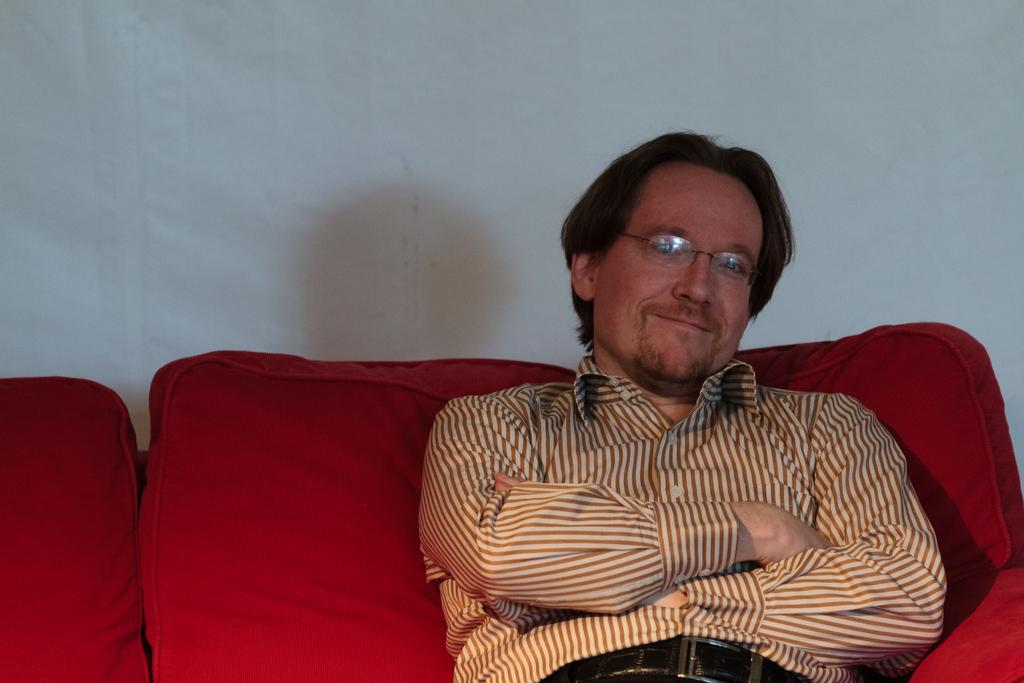Where was the image taken? The image is taken indoors. What can be seen in the background of the image? There is a wall in the background of the image. What is the man in the image doing? The man is sitting on a couch in the middle of the image. What is the man's facial expression? The man has a smiling face. What color is the couch the man is sitting on? The couch is red in color. How many rings does the man have on his fingers in the image? There is no information about rings or the man's fingers in the image, so we cannot determine the number of rings. 